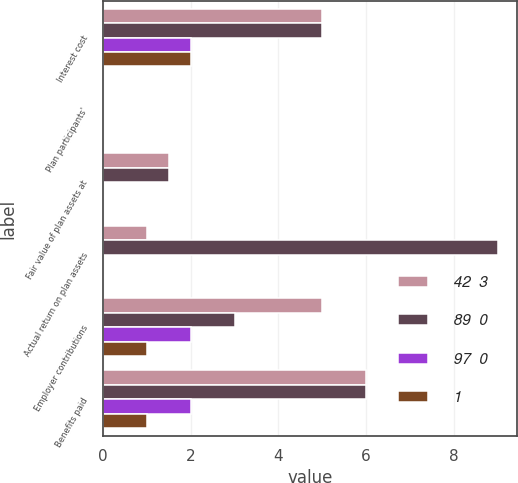<chart> <loc_0><loc_0><loc_500><loc_500><stacked_bar_chart><ecel><fcel>Interest cost<fcel>Plan participants'<fcel>Fair value of plan assets at<fcel>Actual return on plan assets<fcel>Employer contributions<fcel>Benefits paid<nl><fcel>42  3<fcel>5<fcel>0<fcel>1.5<fcel>1<fcel>5<fcel>6<nl><fcel>89  0<fcel>5<fcel>0<fcel>1.5<fcel>9<fcel>3<fcel>6<nl><fcel>97  0<fcel>2<fcel>0<fcel>0<fcel>0<fcel>2<fcel>2<nl><fcel>1<fcel>2<fcel>0<fcel>0<fcel>0<fcel>1<fcel>1<nl></chart> 